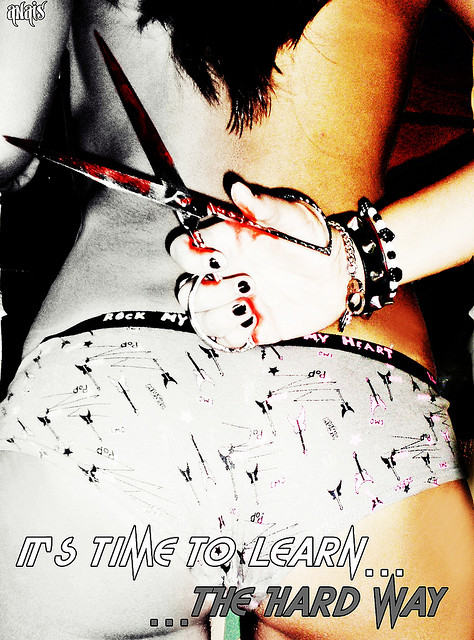Please transcribe the text information in this image. aNais THE HARD WAY TO LEARN... TIME IT'S PoP PoP ROCK 